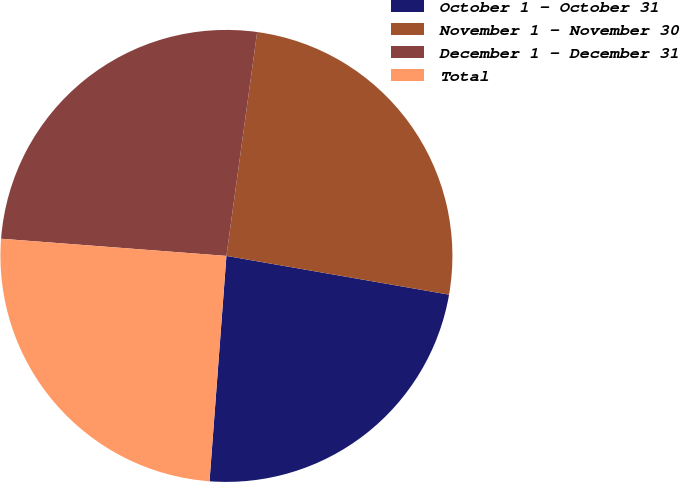<chart> <loc_0><loc_0><loc_500><loc_500><pie_chart><fcel>October 1 - October 31<fcel>November 1 - November 30<fcel>December 1 - December 31<fcel>Total<nl><fcel>23.45%<fcel>25.57%<fcel>25.96%<fcel>25.02%<nl></chart> 